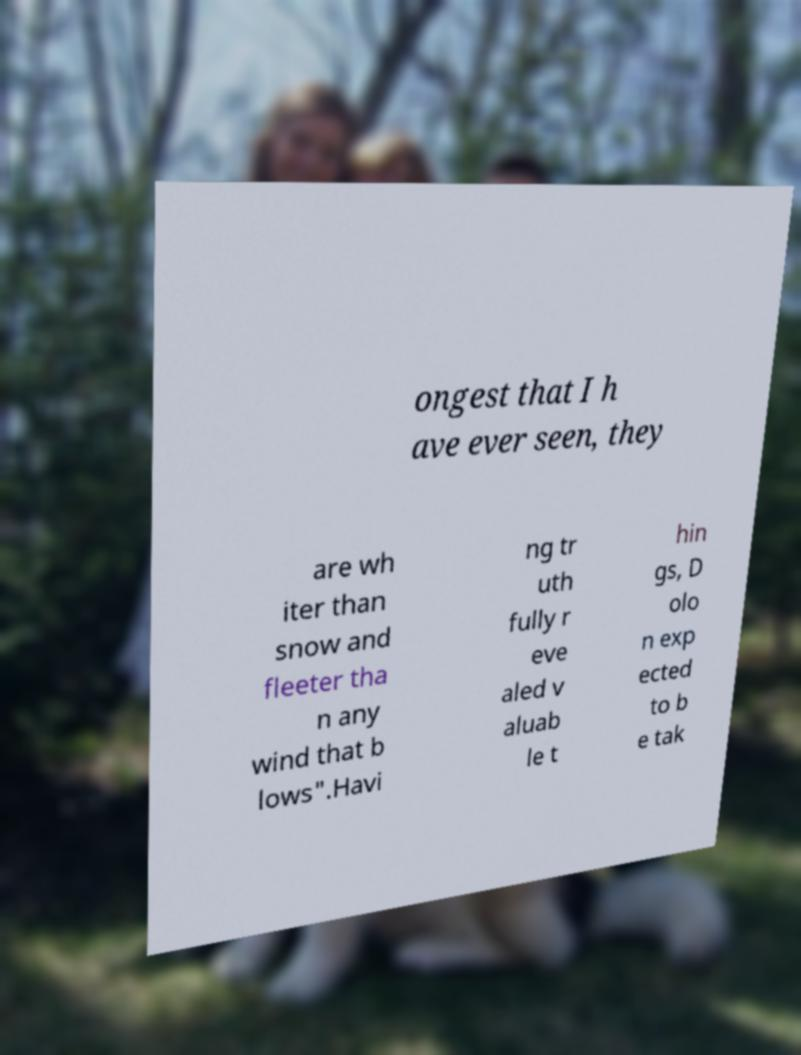Could you assist in decoding the text presented in this image and type it out clearly? ongest that I h ave ever seen, they are wh iter than snow and fleeter tha n any wind that b lows".Havi ng tr uth fully r eve aled v aluab le t hin gs, D olo n exp ected to b e tak 